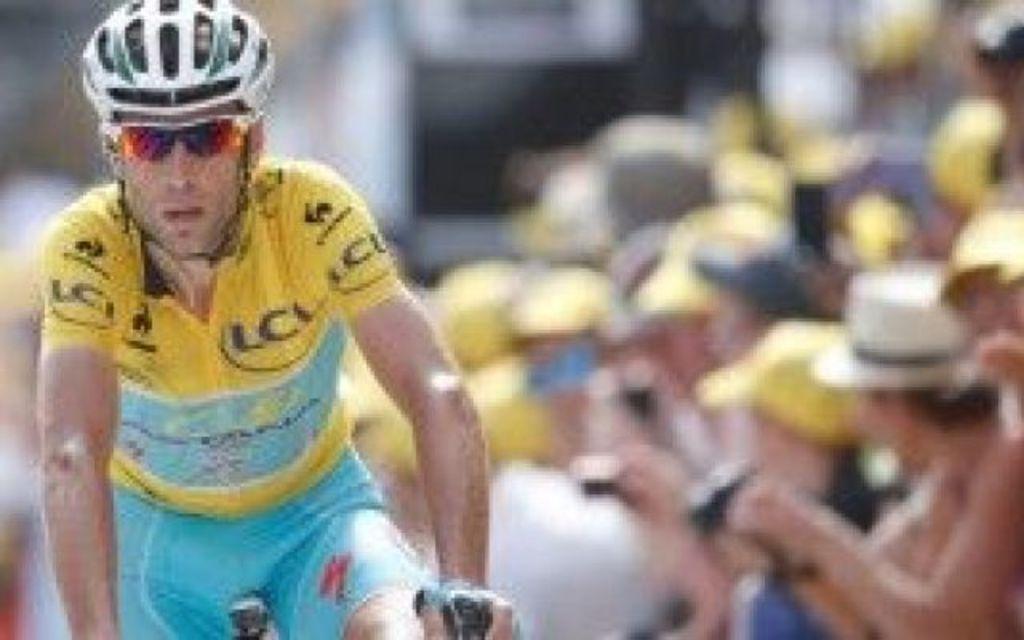Can you describe this image briefly? In the image can see a man wearing clothes, goggles and a helmet, and the man is riding on the bicycle. This is a bicycle and the background is blurred. 